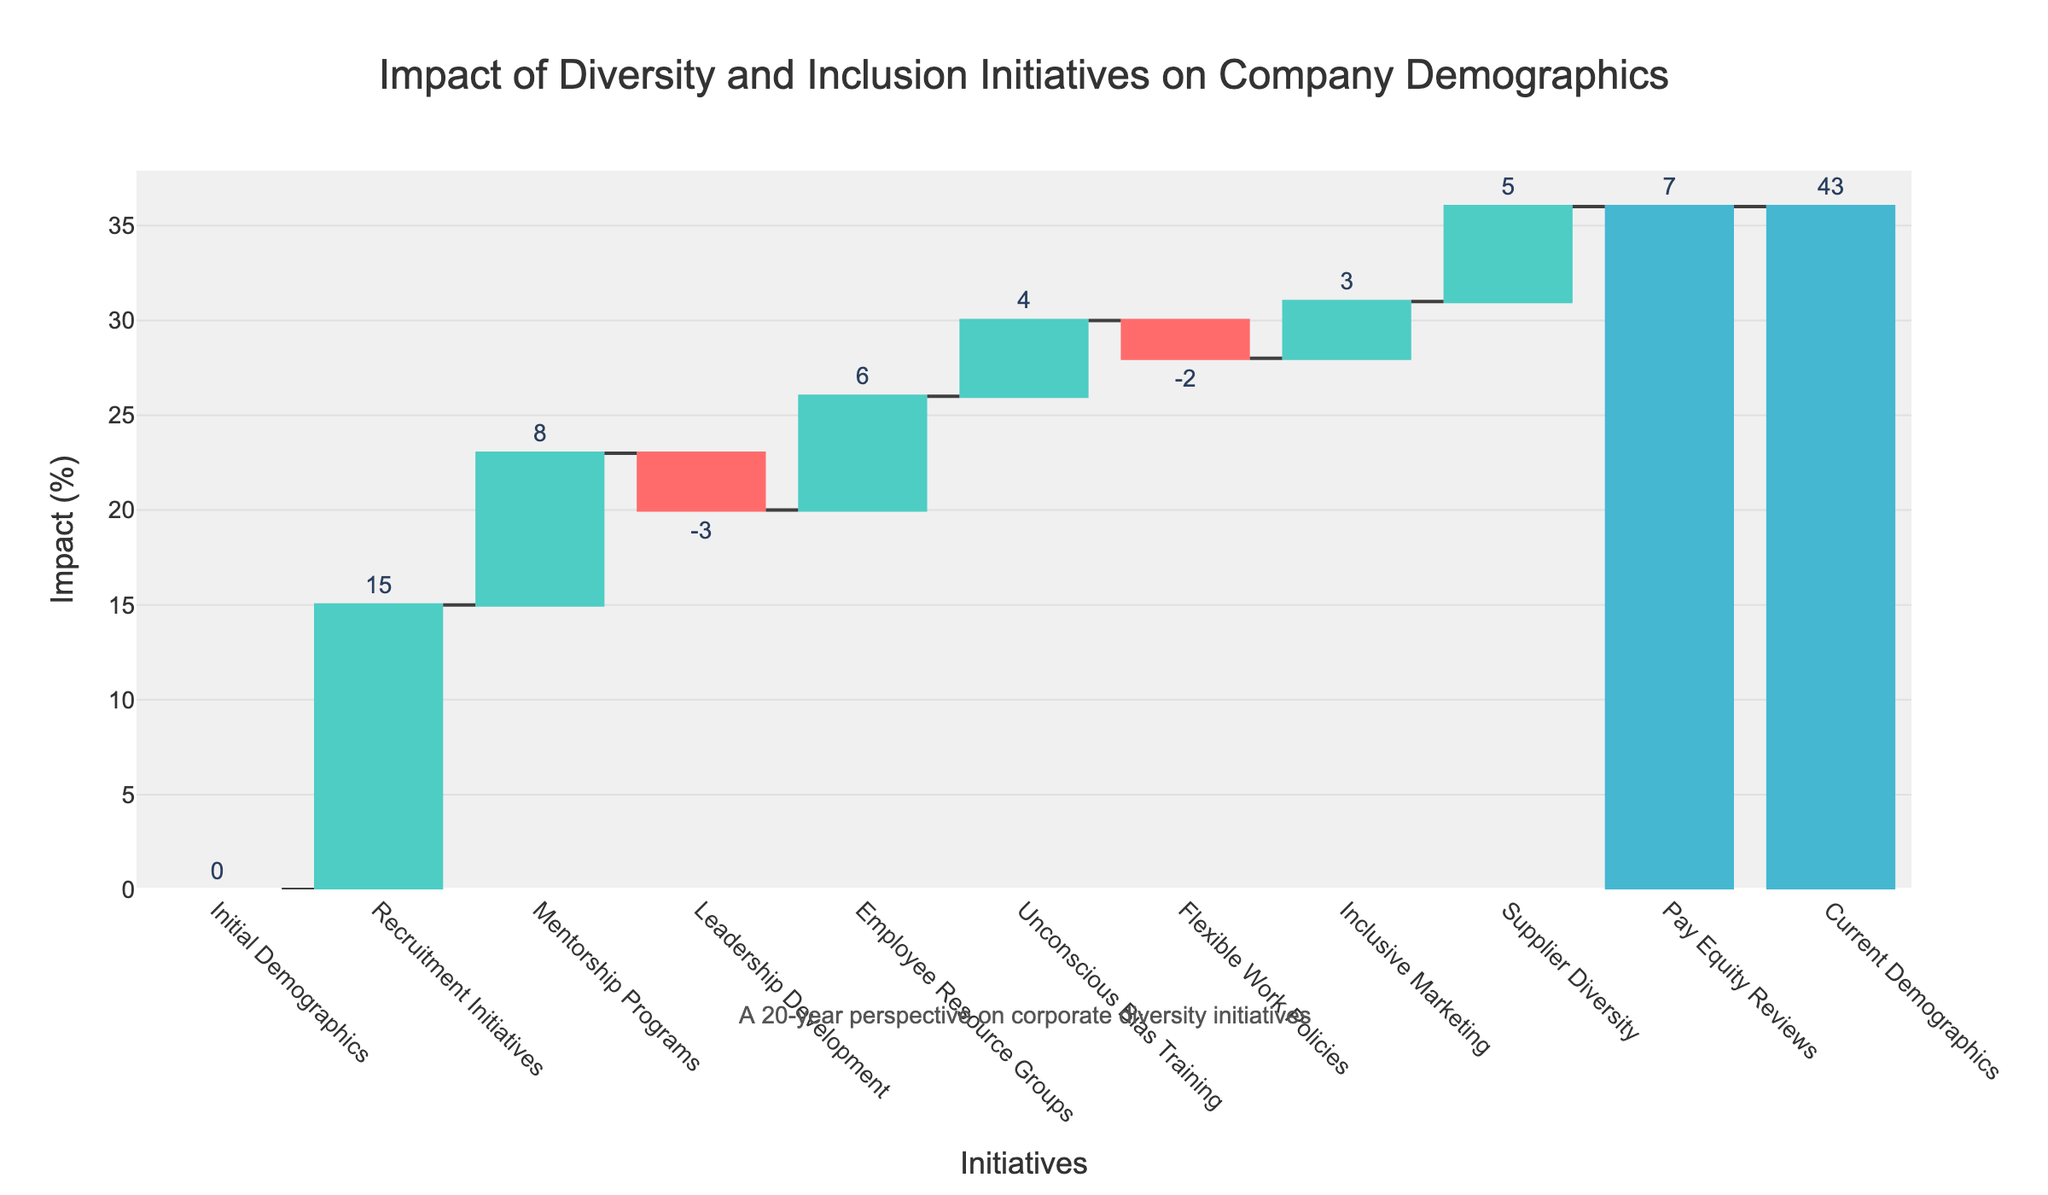What's the total impact of Diversity and Inclusion initiatives on the company demographics? The total impact can be determined by looking at the 'Current Demographics' value, which summarizes the changes from all initiatives. Start from 'Initial Demographics' and move through each category to the end.
Answer: 43 How much did Recruitment Initiatives contribute to the change in demographics? Identify the 'Recruitment Initiatives' category and observe its corresponding value on the chart.
Answer: 15 Which initiative had the largest negative impact on demographics? Look for negative values on the chart and compare them. 'Leadership Development' is the initiative with the most significant negative value.
Answer: Leadership Development What combined impact did Mentorship Programs and Pay Equity Reviews have on demographics? Sum the effects of 'Mentorship Programs' (8) and 'Pay Equity Reviews' (7).
Answer: 15 How does the impact of Employee Resource Groups compare to Flexible Work Policies? Examine the values for both 'Employee Resource Groups' (6) and 'Flexible Work Policies' (-2), and compare them.
Answer: Employee Resource Groups had a greater positive impact What was the net effect of Unconscious Bias Training and Inclusive Marketing on demographics? Sum the effects of 'Unconscious Bias Training' (4) and 'Inclusive Marketing' (3).
Answer: 7 Which initiatives had a positive impact on demographics? Identify initiatives with positive values: 'Recruitment Initiatives' (15), 'Mentorship Programs' (8), 'Employee Resource Groups' (6), 'Unconscious Bias Training' (4), 'Inclusive Marketing' (3), 'Supplier Diversity' (5), and 'Pay Equity Reviews' (7).
Answer: Recruitment Initiatives, Mentorship Programs, Employee Resource Groups, Unconscious Bias Training, Inclusive Marketing, Supplier Diversity, Pay Equity Reviews How did 'Supplier Diversity' contribute to the overall change? Identify 'Supplier Diversity' and its value (5) to see its contribution.
Answer: 5 